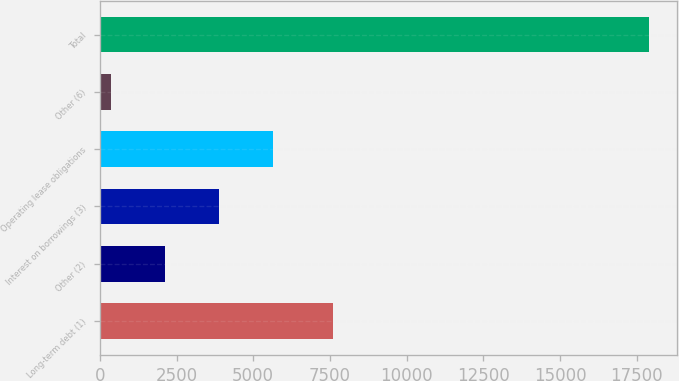Convert chart to OTSL. <chart><loc_0><loc_0><loc_500><loc_500><bar_chart><fcel>Long-term debt (1)<fcel>Other (2)<fcel>Interest on borrowings (3)<fcel>Operating lease obligations<fcel>Other (6)<fcel>Total<nl><fcel>7595<fcel>2120.8<fcel>3875.6<fcel>5630.4<fcel>366<fcel>17914<nl></chart> 